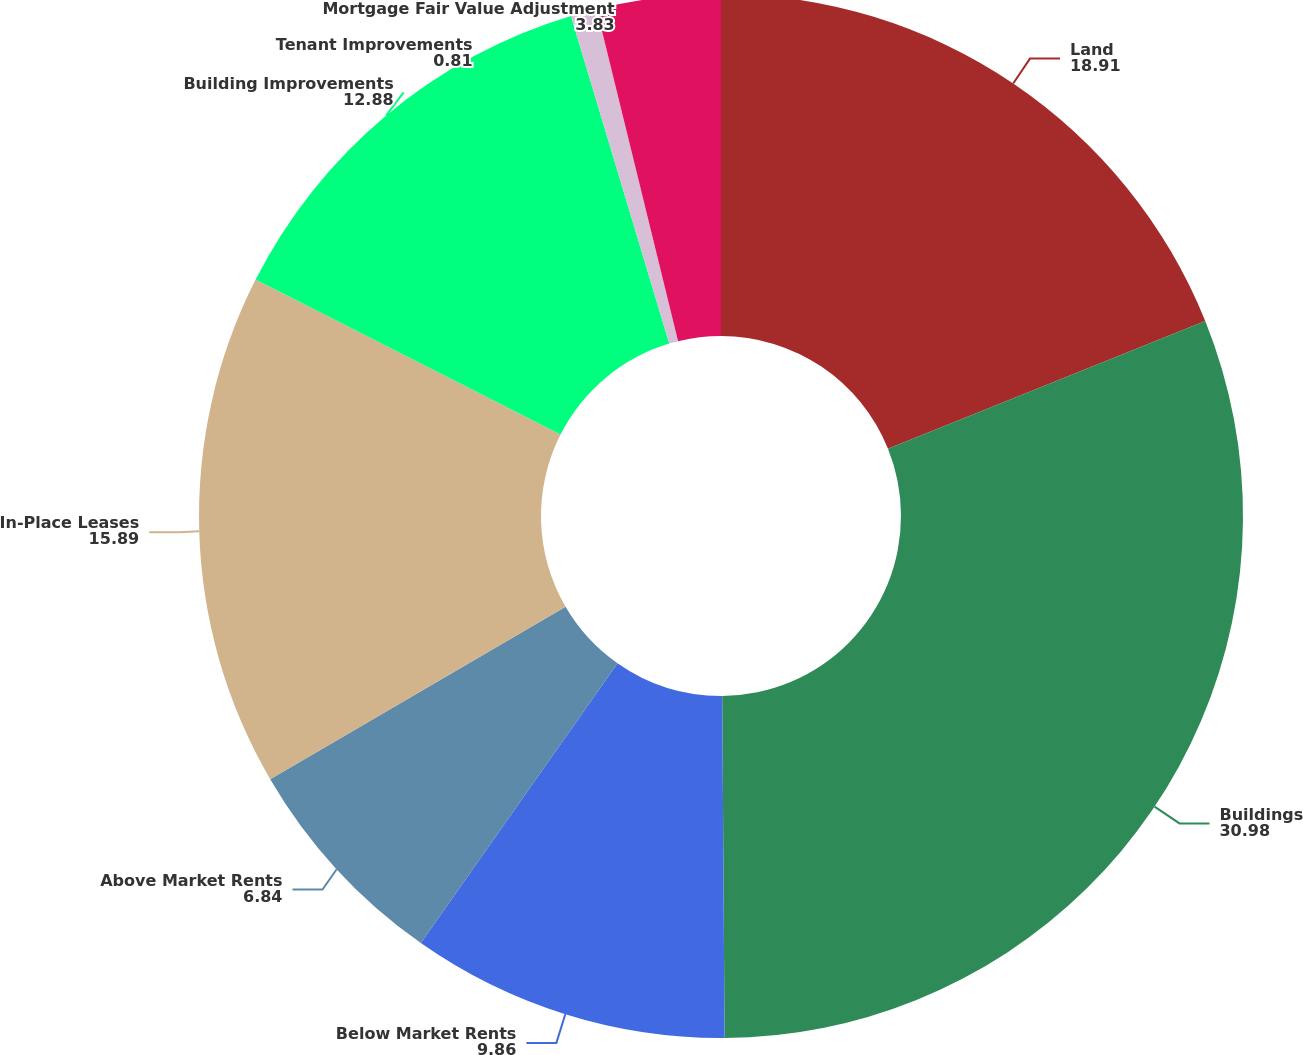Convert chart. <chart><loc_0><loc_0><loc_500><loc_500><pie_chart><fcel>Land<fcel>Buildings<fcel>Below Market Rents<fcel>Above Market Rents<fcel>In-Place Leases<fcel>Building Improvements<fcel>Tenant Improvements<fcel>Mortgage Fair Value Adjustment<nl><fcel>18.91%<fcel>30.98%<fcel>9.86%<fcel>6.84%<fcel>15.89%<fcel>12.88%<fcel>0.81%<fcel>3.83%<nl></chart> 